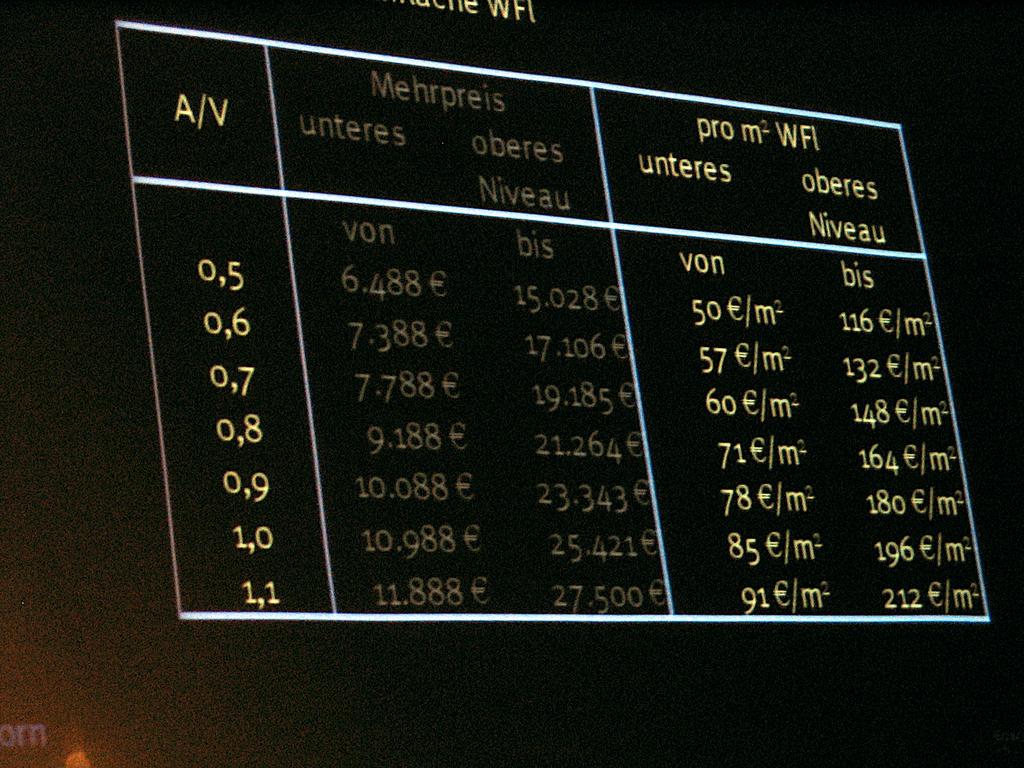What is the audio visual acronym on the left of the board?
Your answer should be very brief. A/v. What are the names of the two columns?
Ensure brevity in your answer.  Unteres and oberes niveau. 